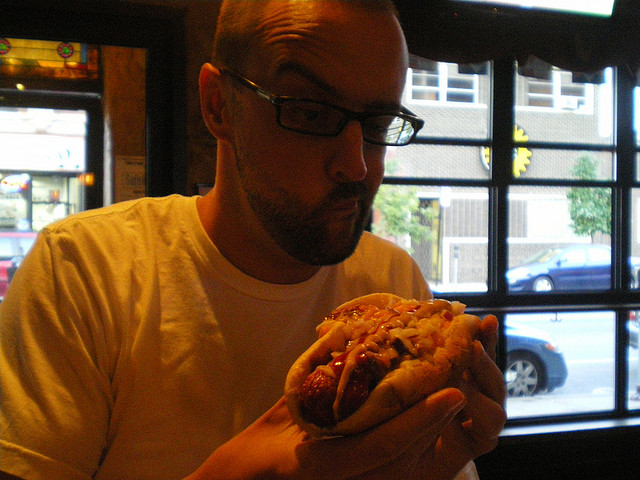<image>Why is the man raising his eyebrow? It is ambiguous why the man is raising his eyebrow. Why is the man raising his eyebrow? I don't know why the man is raising his eyebrow. It can be because he loves his food, he is hungry, or he is considering something. 